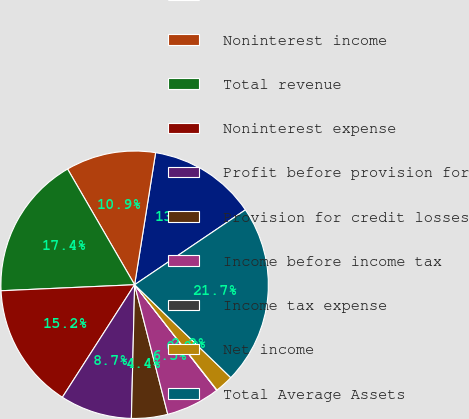<chart> <loc_0><loc_0><loc_500><loc_500><pie_chart><fcel>Net interest income<fcel>Noninterest income<fcel>Total revenue<fcel>Noninterest expense<fcel>Profit before provision for<fcel>Provision for credit losses<fcel>Income before income tax<fcel>Income tax expense<fcel>Net income<fcel>Total Average Assets<nl><fcel>13.03%<fcel>10.87%<fcel>17.36%<fcel>15.2%<fcel>8.7%<fcel>4.37%<fcel>6.54%<fcel>0.04%<fcel>2.21%<fcel>21.69%<nl></chart> 